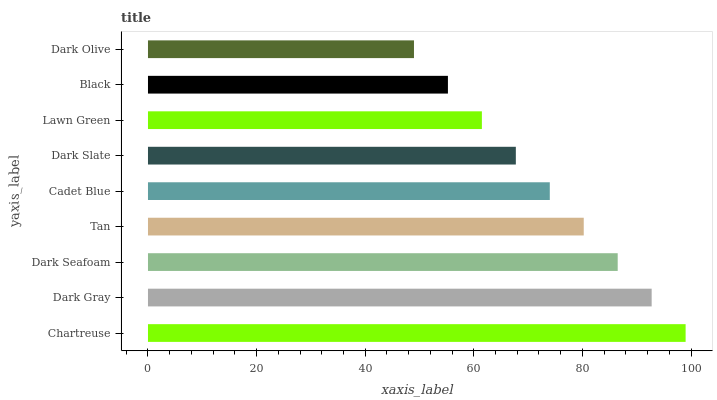Is Dark Olive the minimum?
Answer yes or no. Yes. Is Chartreuse the maximum?
Answer yes or no. Yes. Is Dark Gray the minimum?
Answer yes or no. No. Is Dark Gray the maximum?
Answer yes or no. No. Is Chartreuse greater than Dark Gray?
Answer yes or no. Yes. Is Dark Gray less than Chartreuse?
Answer yes or no. Yes. Is Dark Gray greater than Chartreuse?
Answer yes or no. No. Is Chartreuse less than Dark Gray?
Answer yes or no. No. Is Cadet Blue the high median?
Answer yes or no. Yes. Is Cadet Blue the low median?
Answer yes or no. Yes. Is Tan the high median?
Answer yes or no. No. Is Dark Slate the low median?
Answer yes or no. No. 